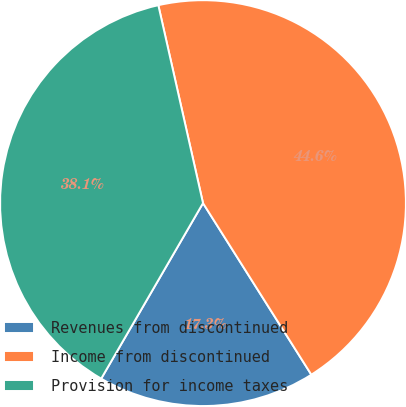<chart> <loc_0><loc_0><loc_500><loc_500><pie_chart><fcel>Revenues from discontinued<fcel>Income from discontinued<fcel>Provision for income taxes<nl><fcel>17.33%<fcel>44.57%<fcel>38.1%<nl></chart> 